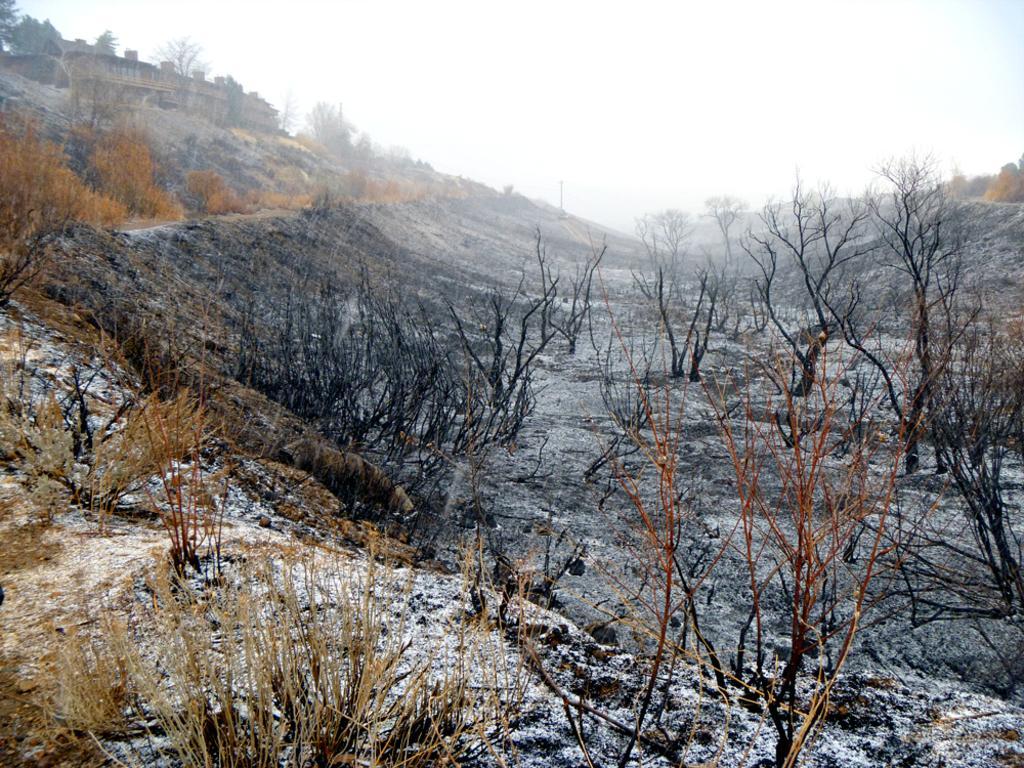Describe this image in one or two sentences. This is an outside view. In this image I can see many plants and trees on the ground. On the left side there is building. At the top of the image I can see the sky. 